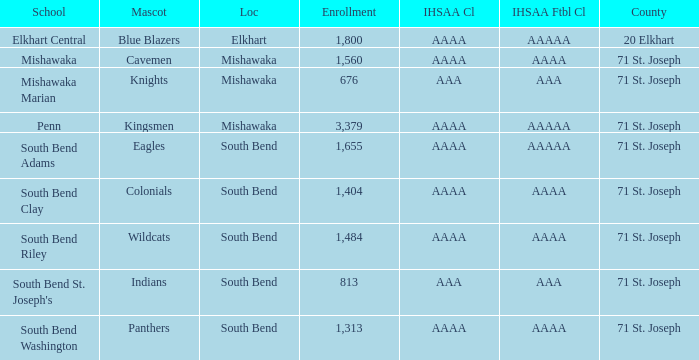What location has kingsmen as the mascot? Mishawaka. 